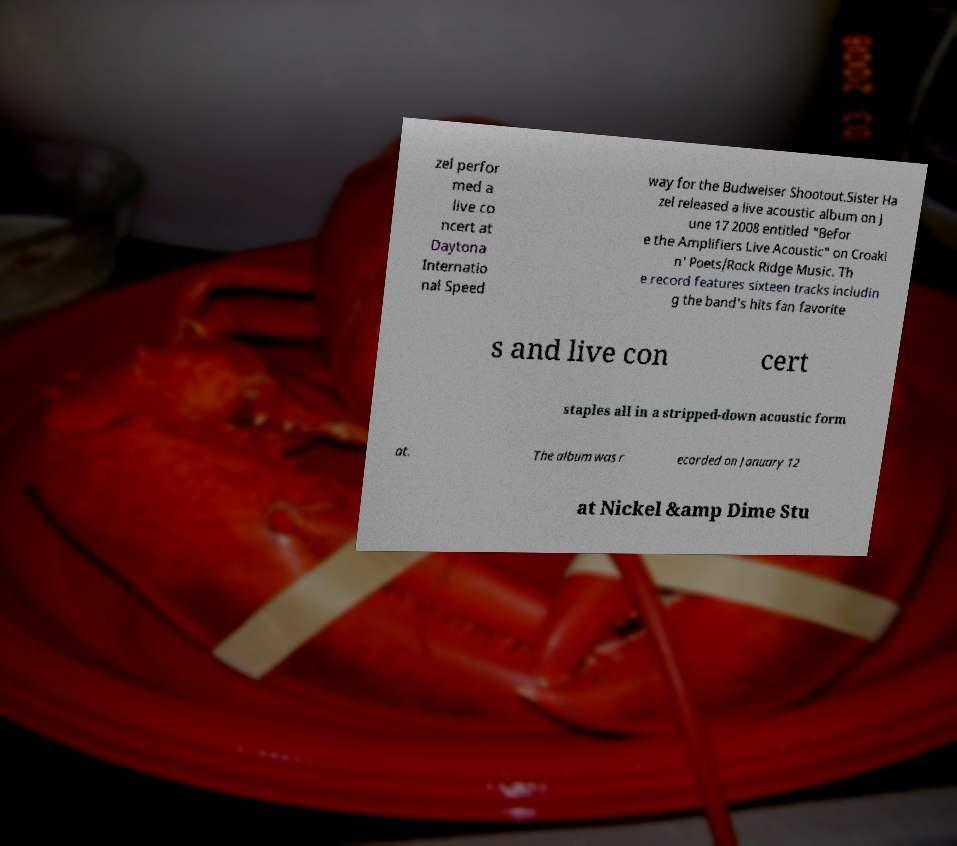Please read and relay the text visible in this image. What does it say? zel perfor med a live co ncert at Daytona Internatio nal Speed way for the Budweiser Shootout.Sister Ha zel released a live acoustic album on J une 17 2008 entitled "Befor e the Amplifiers Live Acoustic" on Croaki n' Poets/Rock Ridge Music. Th e record features sixteen tracks includin g the band's hits fan favorite s and live con cert staples all in a stripped-down acoustic form at. The album was r ecorded on January 12 at Nickel &amp Dime Stu 